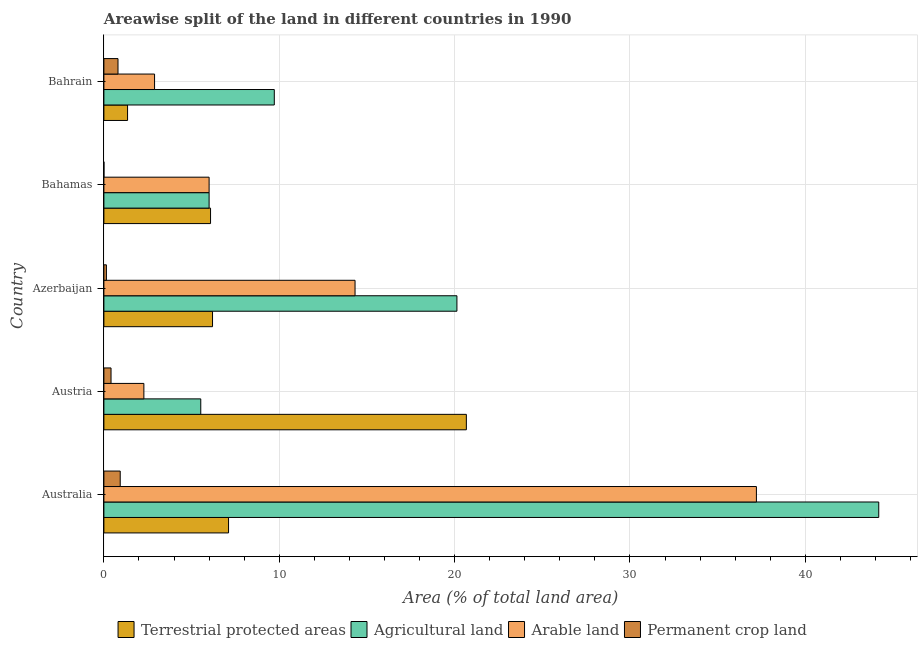How many different coloured bars are there?
Provide a short and direct response. 4. How many groups of bars are there?
Provide a succinct answer. 5. Are the number of bars on each tick of the Y-axis equal?
Your answer should be compact. Yes. How many bars are there on the 3rd tick from the top?
Offer a very short reply. 4. How many bars are there on the 4th tick from the bottom?
Make the answer very short. 4. What is the label of the 1st group of bars from the top?
Your answer should be compact. Bahrain. In how many cases, is the number of bars for a given country not equal to the number of legend labels?
Offer a very short reply. 0. What is the percentage of area under arable land in Bahrain?
Your answer should be compact. 2.89. Across all countries, what is the maximum percentage of area under permanent crop land?
Your answer should be compact. 0.93. Across all countries, what is the minimum percentage of area under permanent crop land?
Keep it short and to the point. 0. In which country was the percentage of area under arable land maximum?
Ensure brevity in your answer.  Australia. In which country was the percentage of area under arable land minimum?
Your answer should be compact. Austria. What is the total percentage of area under permanent crop land in the graph?
Offer a very short reply. 2.29. What is the difference between the percentage of area under agricultural land in Austria and that in Bahrain?
Your response must be concise. -4.19. What is the difference between the percentage of area under arable land in Australia and the percentage of land under terrestrial protection in Bahrain?
Offer a terse response. 35.86. What is the average percentage of land under terrestrial protection per country?
Offer a terse response. 8.28. What is the difference between the percentage of area under permanent crop land and percentage of land under terrestrial protection in Bahamas?
Your answer should be very brief. -6.08. What is the ratio of the percentage of area under permanent crop land in Austria to that in Azerbaijan?
Keep it short and to the point. 2.84. Is the percentage of area under permanent crop land in Austria less than that in Bahamas?
Your answer should be compact. No. What is the difference between the highest and the second highest percentage of area under arable land?
Provide a succinct answer. 22.89. What is the difference between the highest and the lowest percentage of land under terrestrial protection?
Offer a very short reply. 19.32. Is the sum of the percentage of area under arable land in Australia and Bahamas greater than the maximum percentage of area under agricultural land across all countries?
Make the answer very short. No. What does the 4th bar from the top in Austria represents?
Your answer should be compact. Terrestrial protected areas. What does the 4th bar from the bottom in Austria represents?
Ensure brevity in your answer.  Permanent crop land. Is it the case that in every country, the sum of the percentage of land under terrestrial protection and percentage of area under agricultural land is greater than the percentage of area under arable land?
Keep it short and to the point. Yes. How many bars are there?
Your answer should be compact. 20. Are all the bars in the graph horizontal?
Make the answer very short. Yes. What is the difference between two consecutive major ticks on the X-axis?
Give a very brief answer. 10. Are the values on the major ticks of X-axis written in scientific E-notation?
Make the answer very short. No. Does the graph contain any zero values?
Your answer should be compact. No. How are the legend labels stacked?
Provide a short and direct response. Horizontal. What is the title of the graph?
Make the answer very short. Areawise split of the land in different countries in 1990. What is the label or title of the X-axis?
Your answer should be very brief. Area (% of total land area). What is the label or title of the Y-axis?
Your answer should be very brief. Country. What is the Area (% of total land area) in Terrestrial protected areas in Australia?
Offer a very short reply. 7.11. What is the Area (% of total land area) of Agricultural land in Australia?
Offer a very short reply. 44.19. What is the Area (% of total land area) of Arable land in Australia?
Ensure brevity in your answer.  37.21. What is the Area (% of total land area) of Permanent crop land in Australia?
Keep it short and to the point. 0.93. What is the Area (% of total land area) in Terrestrial protected areas in Austria?
Your response must be concise. 20.67. What is the Area (% of total land area) in Agricultural land in Austria?
Offer a very short reply. 5.52. What is the Area (% of total land area) in Arable land in Austria?
Make the answer very short. 2.28. What is the Area (% of total land area) in Permanent crop land in Austria?
Your answer should be very brief. 0.41. What is the Area (% of total land area) of Terrestrial protected areas in Azerbaijan?
Keep it short and to the point. 6.2. What is the Area (% of total land area) of Agricultural land in Azerbaijan?
Offer a very short reply. 20.13. What is the Area (% of total land area) of Arable land in Azerbaijan?
Make the answer very short. 14.32. What is the Area (% of total land area) of Permanent crop land in Azerbaijan?
Make the answer very short. 0.14. What is the Area (% of total land area) of Terrestrial protected areas in Bahamas?
Your answer should be compact. 6.08. What is the Area (% of total land area) in Agricultural land in Bahamas?
Ensure brevity in your answer.  6. What is the Area (% of total land area) of Arable land in Bahamas?
Offer a very short reply. 6. What is the Area (% of total land area) in Permanent crop land in Bahamas?
Your response must be concise. 0. What is the Area (% of total land area) in Terrestrial protected areas in Bahrain?
Keep it short and to the point. 1.35. What is the Area (% of total land area) in Agricultural land in Bahrain?
Provide a short and direct response. 9.72. What is the Area (% of total land area) in Arable land in Bahrain?
Provide a succinct answer. 2.89. What is the Area (% of total land area) of Permanent crop land in Bahrain?
Ensure brevity in your answer.  0.8. Across all countries, what is the maximum Area (% of total land area) in Terrestrial protected areas?
Your response must be concise. 20.67. Across all countries, what is the maximum Area (% of total land area) of Agricultural land?
Your answer should be very brief. 44.19. Across all countries, what is the maximum Area (% of total land area) of Arable land?
Your response must be concise. 37.21. Across all countries, what is the maximum Area (% of total land area) of Permanent crop land?
Your answer should be very brief. 0.93. Across all countries, what is the minimum Area (% of total land area) in Terrestrial protected areas?
Provide a short and direct response. 1.35. Across all countries, what is the minimum Area (% of total land area) in Agricultural land?
Your response must be concise. 5.52. Across all countries, what is the minimum Area (% of total land area) of Arable land?
Provide a succinct answer. 2.28. Across all countries, what is the minimum Area (% of total land area) in Permanent crop land?
Your response must be concise. 0. What is the total Area (% of total land area) in Terrestrial protected areas in the graph?
Your answer should be compact. 41.4. What is the total Area (% of total land area) of Agricultural land in the graph?
Offer a very short reply. 85.56. What is the total Area (% of total land area) in Arable land in the graph?
Provide a short and direct response. 62.7. What is the total Area (% of total land area) in Permanent crop land in the graph?
Offer a very short reply. 2.29. What is the difference between the Area (% of total land area) in Terrestrial protected areas in Australia and that in Austria?
Make the answer very short. -13.56. What is the difference between the Area (% of total land area) of Agricultural land in Australia and that in Austria?
Provide a short and direct response. 38.66. What is the difference between the Area (% of total land area) of Arable land in Australia and that in Austria?
Offer a terse response. 34.93. What is the difference between the Area (% of total land area) of Permanent crop land in Australia and that in Austria?
Your answer should be very brief. 0.52. What is the difference between the Area (% of total land area) in Terrestrial protected areas in Australia and that in Azerbaijan?
Give a very brief answer. 0.91. What is the difference between the Area (% of total land area) in Agricultural land in Australia and that in Azerbaijan?
Offer a terse response. 24.05. What is the difference between the Area (% of total land area) of Arable land in Australia and that in Azerbaijan?
Your response must be concise. 22.89. What is the difference between the Area (% of total land area) in Permanent crop land in Australia and that in Azerbaijan?
Provide a succinct answer. 0.79. What is the difference between the Area (% of total land area) of Terrestrial protected areas in Australia and that in Bahamas?
Offer a very short reply. 1.03. What is the difference between the Area (% of total land area) in Agricultural land in Australia and that in Bahamas?
Ensure brevity in your answer.  38.19. What is the difference between the Area (% of total land area) in Arable land in Australia and that in Bahamas?
Your response must be concise. 31.21. What is the difference between the Area (% of total land area) of Permanent crop land in Australia and that in Bahamas?
Make the answer very short. 0.93. What is the difference between the Area (% of total land area) of Terrestrial protected areas in Australia and that in Bahrain?
Give a very brief answer. 5.76. What is the difference between the Area (% of total land area) of Agricultural land in Australia and that in Bahrain?
Your response must be concise. 34.47. What is the difference between the Area (% of total land area) in Arable land in Australia and that in Bahrain?
Keep it short and to the point. 34.32. What is the difference between the Area (% of total land area) in Permanent crop land in Australia and that in Bahrain?
Make the answer very short. 0.13. What is the difference between the Area (% of total land area) in Terrestrial protected areas in Austria and that in Azerbaijan?
Give a very brief answer. 14.47. What is the difference between the Area (% of total land area) in Agricultural land in Austria and that in Azerbaijan?
Your response must be concise. -14.61. What is the difference between the Area (% of total land area) in Arable land in Austria and that in Azerbaijan?
Offer a terse response. -12.04. What is the difference between the Area (% of total land area) in Permanent crop land in Austria and that in Azerbaijan?
Ensure brevity in your answer.  0.26. What is the difference between the Area (% of total land area) of Terrestrial protected areas in Austria and that in Bahamas?
Keep it short and to the point. 14.59. What is the difference between the Area (% of total land area) of Agricultural land in Austria and that in Bahamas?
Offer a terse response. -0.48. What is the difference between the Area (% of total land area) of Arable land in Austria and that in Bahamas?
Your answer should be compact. -3.72. What is the difference between the Area (% of total land area) in Permanent crop land in Austria and that in Bahamas?
Give a very brief answer. 0.4. What is the difference between the Area (% of total land area) of Terrestrial protected areas in Austria and that in Bahrain?
Offer a very short reply. 19.32. What is the difference between the Area (% of total land area) in Agricultural land in Austria and that in Bahrain?
Provide a short and direct response. -4.19. What is the difference between the Area (% of total land area) of Arable land in Austria and that in Bahrain?
Ensure brevity in your answer.  -0.61. What is the difference between the Area (% of total land area) in Permanent crop land in Austria and that in Bahrain?
Your answer should be compact. -0.4. What is the difference between the Area (% of total land area) in Terrestrial protected areas in Azerbaijan and that in Bahamas?
Your answer should be very brief. 0.11. What is the difference between the Area (% of total land area) in Agricultural land in Azerbaijan and that in Bahamas?
Ensure brevity in your answer.  14.13. What is the difference between the Area (% of total land area) of Arable land in Azerbaijan and that in Bahamas?
Give a very brief answer. 8.32. What is the difference between the Area (% of total land area) of Permanent crop land in Azerbaijan and that in Bahamas?
Offer a terse response. 0.14. What is the difference between the Area (% of total land area) in Terrestrial protected areas in Azerbaijan and that in Bahrain?
Ensure brevity in your answer.  4.85. What is the difference between the Area (% of total land area) of Agricultural land in Azerbaijan and that in Bahrain?
Offer a very short reply. 10.41. What is the difference between the Area (% of total land area) of Arable land in Azerbaijan and that in Bahrain?
Offer a terse response. 11.43. What is the difference between the Area (% of total land area) in Permanent crop land in Azerbaijan and that in Bahrain?
Your answer should be compact. -0.66. What is the difference between the Area (% of total land area) in Terrestrial protected areas in Bahamas and that in Bahrain?
Provide a succinct answer. 4.73. What is the difference between the Area (% of total land area) of Agricultural land in Bahamas and that in Bahrain?
Keep it short and to the point. -3.72. What is the difference between the Area (% of total land area) of Arable land in Bahamas and that in Bahrain?
Your answer should be very brief. 3.11. What is the difference between the Area (% of total land area) in Permanent crop land in Bahamas and that in Bahrain?
Give a very brief answer. -0.8. What is the difference between the Area (% of total land area) of Terrestrial protected areas in Australia and the Area (% of total land area) of Agricultural land in Austria?
Make the answer very short. 1.58. What is the difference between the Area (% of total land area) of Terrestrial protected areas in Australia and the Area (% of total land area) of Arable land in Austria?
Provide a succinct answer. 4.83. What is the difference between the Area (% of total land area) in Terrestrial protected areas in Australia and the Area (% of total land area) in Permanent crop land in Austria?
Your answer should be compact. 6.7. What is the difference between the Area (% of total land area) in Agricultural land in Australia and the Area (% of total land area) in Arable land in Austria?
Give a very brief answer. 41.91. What is the difference between the Area (% of total land area) of Agricultural land in Australia and the Area (% of total land area) of Permanent crop land in Austria?
Offer a very short reply. 43.78. What is the difference between the Area (% of total land area) in Arable land in Australia and the Area (% of total land area) in Permanent crop land in Austria?
Offer a very short reply. 36.8. What is the difference between the Area (% of total land area) in Terrestrial protected areas in Australia and the Area (% of total land area) in Agricultural land in Azerbaijan?
Provide a short and direct response. -13.02. What is the difference between the Area (% of total land area) in Terrestrial protected areas in Australia and the Area (% of total land area) in Arable land in Azerbaijan?
Your answer should be very brief. -7.21. What is the difference between the Area (% of total land area) in Terrestrial protected areas in Australia and the Area (% of total land area) in Permanent crop land in Azerbaijan?
Offer a very short reply. 6.97. What is the difference between the Area (% of total land area) in Agricultural land in Australia and the Area (% of total land area) in Arable land in Azerbaijan?
Provide a succinct answer. 29.86. What is the difference between the Area (% of total land area) of Agricultural land in Australia and the Area (% of total land area) of Permanent crop land in Azerbaijan?
Your response must be concise. 44.04. What is the difference between the Area (% of total land area) in Arable land in Australia and the Area (% of total land area) in Permanent crop land in Azerbaijan?
Your response must be concise. 37.07. What is the difference between the Area (% of total land area) in Terrestrial protected areas in Australia and the Area (% of total land area) in Agricultural land in Bahamas?
Ensure brevity in your answer.  1.11. What is the difference between the Area (% of total land area) in Terrestrial protected areas in Australia and the Area (% of total land area) in Arable land in Bahamas?
Your answer should be compact. 1.11. What is the difference between the Area (% of total land area) in Terrestrial protected areas in Australia and the Area (% of total land area) in Permanent crop land in Bahamas?
Your response must be concise. 7.11. What is the difference between the Area (% of total land area) of Agricultural land in Australia and the Area (% of total land area) of Arable land in Bahamas?
Make the answer very short. 38.19. What is the difference between the Area (% of total land area) of Agricultural land in Australia and the Area (% of total land area) of Permanent crop land in Bahamas?
Provide a short and direct response. 44.18. What is the difference between the Area (% of total land area) of Arable land in Australia and the Area (% of total land area) of Permanent crop land in Bahamas?
Ensure brevity in your answer.  37.21. What is the difference between the Area (% of total land area) of Terrestrial protected areas in Australia and the Area (% of total land area) of Agricultural land in Bahrain?
Give a very brief answer. -2.61. What is the difference between the Area (% of total land area) of Terrestrial protected areas in Australia and the Area (% of total land area) of Arable land in Bahrain?
Offer a terse response. 4.22. What is the difference between the Area (% of total land area) of Terrestrial protected areas in Australia and the Area (% of total land area) of Permanent crop land in Bahrain?
Your answer should be compact. 6.3. What is the difference between the Area (% of total land area) of Agricultural land in Australia and the Area (% of total land area) of Arable land in Bahrain?
Your answer should be compact. 41.3. What is the difference between the Area (% of total land area) of Agricultural land in Australia and the Area (% of total land area) of Permanent crop land in Bahrain?
Provide a succinct answer. 43.38. What is the difference between the Area (% of total land area) of Arable land in Australia and the Area (% of total land area) of Permanent crop land in Bahrain?
Make the answer very short. 36.4. What is the difference between the Area (% of total land area) of Terrestrial protected areas in Austria and the Area (% of total land area) of Agricultural land in Azerbaijan?
Give a very brief answer. 0.54. What is the difference between the Area (% of total land area) in Terrestrial protected areas in Austria and the Area (% of total land area) in Arable land in Azerbaijan?
Keep it short and to the point. 6.35. What is the difference between the Area (% of total land area) in Terrestrial protected areas in Austria and the Area (% of total land area) in Permanent crop land in Azerbaijan?
Keep it short and to the point. 20.53. What is the difference between the Area (% of total land area) of Agricultural land in Austria and the Area (% of total land area) of Arable land in Azerbaijan?
Your answer should be very brief. -8.8. What is the difference between the Area (% of total land area) in Agricultural land in Austria and the Area (% of total land area) in Permanent crop land in Azerbaijan?
Offer a terse response. 5.38. What is the difference between the Area (% of total land area) in Arable land in Austria and the Area (% of total land area) in Permanent crop land in Azerbaijan?
Provide a succinct answer. 2.14. What is the difference between the Area (% of total land area) in Terrestrial protected areas in Austria and the Area (% of total land area) in Agricultural land in Bahamas?
Make the answer very short. 14.67. What is the difference between the Area (% of total land area) in Terrestrial protected areas in Austria and the Area (% of total land area) in Arable land in Bahamas?
Your answer should be very brief. 14.67. What is the difference between the Area (% of total land area) of Terrestrial protected areas in Austria and the Area (% of total land area) of Permanent crop land in Bahamas?
Your answer should be very brief. 20.67. What is the difference between the Area (% of total land area) of Agricultural land in Austria and the Area (% of total land area) of Arable land in Bahamas?
Give a very brief answer. -0.48. What is the difference between the Area (% of total land area) of Agricultural land in Austria and the Area (% of total land area) of Permanent crop land in Bahamas?
Provide a succinct answer. 5.52. What is the difference between the Area (% of total land area) of Arable land in Austria and the Area (% of total land area) of Permanent crop land in Bahamas?
Provide a short and direct response. 2.28. What is the difference between the Area (% of total land area) in Terrestrial protected areas in Austria and the Area (% of total land area) in Agricultural land in Bahrain?
Your response must be concise. 10.95. What is the difference between the Area (% of total land area) in Terrestrial protected areas in Austria and the Area (% of total land area) in Arable land in Bahrain?
Your answer should be very brief. 17.78. What is the difference between the Area (% of total land area) in Terrestrial protected areas in Austria and the Area (% of total land area) in Permanent crop land in Bahrain?
Make the answer very short. 19.86. What is the difference between the Area (% of total land area) of Agricultural land in Austria and the Area (% of total land area) of Arable land in Bahrain?
Your answer should be very brief. 2.63. What is the difference between the Area (% of total land area) of Agricultural land in Austria and the Area (% of total land area) of Permanent crop land in Bahrain?
Offer a terse response. 4.72. What is the difference between the Area (% of total land area) of Arable land in Austria and the Area (% of total land area) of Permanent crop land in Bahrain?
Keep it short and to the point. 1.47. What is the difference between the Area (% of total land area) of Terrestrial protected areas in Azerbaijan and the Area (% of total land area) of Agricultural land in Bahamas?
Ensure brevity in your answer.  0.2. What is the difference between the Area (% of total land area) in Terrestrial protected areas in Azerbaijan and the Area (% of total land area) in Arable land in Bahamas?
Your answer should be compact. 0.2. What is the difference between the Area (% of total land area) of Terrestrial protected areas in Azerbaijan and the Area (% of total land area) of Permanent crop land in Bahamas?
Your response must be concise. 6.19. What is the difference between the Area (% of total land area) in Agricultural land in Azerbaijan and the Area (% of total land area) in Arable land in Bahamas?
Offer a terse response. 14.13. What is the difference between the Area (% of total land area) in Agricultural land in Azerbaijan and the Area (% of total land area) in Permanent crop land in Bahamas?
Your answer should be very brief. 20.13. What is the difference between the Area (% of total land area) in Arable land in Azerbaijan and the Area (% of total land area) in Permanent crop land in Bahamas?
Your answer should be very brief. 14.32. What is the difference between the Area (% of total land area) in Terrestrial protected areas in Azerbaijan and the Area (% of total land area) in Agricultural land in Bahrain?
Your answer should be very brief. -3.52. What is the difference between the Area (% of total land area) of Terrestrial protected areas in Azerbaijan and the Area (% of total land area) of Arable land in Bahrain?
Ensure brevity in your answer.  3.31. What is the difference between the Area (% of total land area) of Terrestrial protected areas in Azerbaijan and the Area (% of total land area) of Permanent crop land in Bahrain?
Your answer should be compact. 5.39. What is the difference between the Area (% of total land area) in Agricultural land in Azerbaijan and the Area (% of total land area) in Arable land in Bahrain?
Your response must be concise. 17.24. What is the difference between the Area (% of total land area) in Agricultural land in Azerbaijan and the Area (% of total land area) in Permanent crop land in Bahrain?
Make the answer very short. 19.33. What is the difference between the Area (% of total land area) of Arable land in Azerbaijan and the Area (% of total land area) of Permanent crop land in Bahrain?
Offer a terse response. 13.52. What is the difference between the Area (% of total land area) of Terrestrial protected areas in Bahamas and the Area (% of total land area) of Agricultural land in Bahrain?
Make the answer very short. -3.64. What is the difference between the Area (% of total land area) of Terrestrial protected areas in Bahamas and the Area (% of total land area) of Arable land in Bahrain?
Your answer should be very brief. 3.19. What is the difference between the Area (% of total land area) of Terrestrial protected areas in Bahamas and the Area (% of total land area) of Permanent crop land in Bahrain?
Make the answer very short. 5.28. What is the difference between the Area (% of total land area) of Agricultural land in Bahamas and the Area (% of total land area) of Arable land in Bahrain?
Ensure brevity in your answer.  3.11. What is the difference between the Area (% of total land area) of Agricultural land in Bahamas and the Area (% of total land area) of Permanent crop land in Bahrain?
Provide a short and direct response. 5.2. What is the difference between the Area (% of total land area) in Arable land in Bahamas and the Area (% of total land area) in Permanent crop land in Bahrain?
Offer a terse response. 5.2. What is the average Area (% of total land area) of Terrestrial protected areas per country?
Provide a short and direct response. 8.28. What is the average Area (% of total land area) of Agricultural land per country?
Provide a short and direct response. 17.11. What is the average Area (% of total land area) in Arable land per country?
Provide a succinct answer. 12.54. What is the average Area (% of total land area) in Permanent crop land per country?
Ensure brevity in your answer.  0.46. What is the difference between the Area (% of total land area) of Terrestrial protected areas and Area (% of total land area) of Agricultural land in Australia?
Make the answer very short. -37.08. What is the difference between the Area (% of total land area) of Terrestrial protected areas and Area (% of total land area) of Arable land in Australia?
Offer a very short reply. -30.1. What is the difference between the Area (% of total land area) in Terrestrial protected areas and Area (% of total land area) in Permanent crop land in Australia?
Provide a succinct answer. 6.18. What is the difference between the Area (% of total land area) in Agricultural land and Area (% of total land area) in Arable land in Australia?
Keep it short and to the point. 6.98. What is the difference between the Area (% of total land area) in Agricultural land and Area (% of total land area) in Permanent crop land in Australia?
Provide a succinct answer. 43.25. What is the difference between the Area (% of total land area) of Arable land and Area (% of total land area) of Permanent crop land in Australia?
Your response must be concise. 36.28. What is the difference between the Area (% of total land area) in Terrestrial protected areas and Area (% of total land area) in Agricultural land in Austria?
Offer a very short reply. 15.15. What is the difference between the Area (% of total land area) of Terrestrial protected areas and Area (% of total land area) of Arable land in Austria?
Your answer should be very brief. 18.39. What is the difference between the Area (% of total land area) of Terrestrial protected areas and Area (% of total land area) of Permanent crop land in Austria?
Ensure brevity in your answer.  20.26. What is the difference between the Area (% of total land area) of Agricultural land and Area (% of total land area) of Arable land in Austria?
Your answer should be very brief. 3.24. What is the difference between the Area (% of total land area) in Agricultural land and Area (% of total land area) in Permanent crop land in Austria?
Your response must be concise. 5.12. What is the difference between the Area (% of total land area) of Arable land and Area (% of total land area) of Permanent crop land in Austria?
Offer a very short reply. 1.87. What is the difference between the Area (% of total land area) in Terrestrial protected areas and Area (% of total land area) in Agricultural land in Azerbaijan?
Keep it short and to the point. -13.94. What is the difference between the Area (% of total land area) in Terrestrial protected areas and Area (% of total land area) in Arable land in Azerbaijan?
Offer a very short reply. -8.13. What is the difference between the Area (% of total land area) in Terrestrial protected areas and Area (% of total land area) in Permanent crop land in Azerbaijan?
Your answer should be very brief. 6.05. What is the difference between the Area (% of total land area) of Agricultural land and Area (% of total land area) of Arable land in Azerbaijan?
Give a very brief answer. 5.81. What is the difference between the Area (% of total land area) in Agricultural land and Area (% of total land area) in Permanent crop land in Azerbaijan?
Provide a short and direct response. 19.99. What is the difference between the Area (% of total land area) of Arable land and Area (% of total land area) of Permanent crop land in Azerbaijan?
Your answer should be compact. 14.18. What is the difference between the Area (% of total land area) in Terrestrial protected areas and Area (% of total land area) in Agricultural land in Bahamas?
Your response must be concise. 0.08. What is the difference between the Area (% of total land area) of Terrestrial protected areas and Area (% of total land area) of Arable land in Bahamas?
Keep it short and to the point. 0.08. What is the difference between the Area (% of total land area) of Terrestrial protected areas and Area (% of total land area) of Permanent crop land in Bahamas?
Provide a succinct answer. 6.08. What is the difference between the Area (% of total land area) of Agricultural land and Area (% of total land area) of Arable land in Bahamas?
Provide a short and direct response. 0. What is the difference between the Area (% of total land area) of Agricultural land and Area (% of total land area) of Permanent crop land in Bahamas?
Provide a short and direct response. 6. What is the difference between the Area (% of total land area) of Arable land and Area (% of total land area) of Permanent crop land in Bahamas?
Give a very brief answer. 6. What is the difference between the Area (% of total land area) in Terrestrial protected areas and Area (% of total land area) in Agricultural land in Bahrain?
Your response must be concise. -8.37. What is the difference between the Area (% of total land area) in Terrestrial protected areas and Area (% of total land area) in Arable land in Bahrain?
Your answer should be very brief. -1.54. What is the difference between the Area (% of total land area) of Terrestrial protected areas and Area (% of total land area) of Permanent crop land in Bahrain?
Ensure brevity in your answer.  0.55. What is the difference between the Area (% of total land area) of Agricultural land and Area (% of total land area) of Arable land in Bahrain?
Your response must be concise. 6.83. What is the difference between the Area (% of total land area) in Agricultural land and Area (% of total land area) in Permanent crop land in Bahrain?
Provide a short and direct response. 8.91. What is the difference between the Area (% of total land area) of Arable land and Area (% of total land area) of Permanent crop land in Bahrain?
Offer a very short reply. 2.08. What is the ratio of the Area (% of total land area) of Terrestrial protected areas in Australia to that in Austria?
Ensure brevity in your answer.  0.34. What is the ratio of the Area (% of total land area) in Agricultural land in Australia to that in Austria?
Your response must be concise. 8. What is the ratio of the Area (% of total land area) of Arable land in Australia to that in Austria?
Keep it short and to the point. 16.32. What is the ratio of the Area (% of total land area) in Permanent crop land in Australia to that in Austria?
Provide a succinct answer. 2.29. What is the ratio of the Area (% of total land area) in Terrestrial protected areas in Australia to that in Azerbaijan?
Your response must be concise. 1.15. What is the ratio of the Area (% of total land area) in Agricultural land in Australia to that in Azerbaijan?
Your answer should be very brief. 2.19. What is the ratio of the Area (% of total land area) in Arable land in Australia to that in Azerbaijan?
Provide a succinct answer. 2.6. What is the ratio of the Area (% of total land area) of Permanent crop land in Australia to that in Azerbaijan?
Your answer should be very brief. 6.51. What is the ratio of the Area (% of total land area) in Terrestrial protected areas in Australia to that in Bahamas?
Offer a terse response. 1.17. What is the ratio of the Area (% of total land area) in Agricultural land in Australia to that in Bahamas?
Provide a succinct answer. 7.36. What is the ratio of the Area (% of total land area) in Arable land in Australia to that in Bahamas?
Your answer should be compact. 6.2. What is the ratio of the Area (% of total land area) in Permanent crop land in Australia to that in Bahamas?
Your answer should be compact. 527.73. What is the ratio of the Area (% of total land area) of Terrestrial protected areas in Australia to that in Bahrain?
Your answer should be compact. 5.27. What is the ratio of the Area (% of total land area) of Agricultural land in Australia to that in Bahrain?
Make the answer very short. 4.55. What is the ratio of the Area (% of total land area) in Arable land in Australia to that in Bahrain?
Provide a succinct answer. 12.88. What is the ratio of the Area (% of total land area) in Permanent crop land in Australia to that in Bahrain?
Offer a very short reply. 1.16. What is the ratio of the Area (% of total land area) in Terrestrial protected areas in Austria to that in Azerbaijan?
Give a very brief answer. 3.34. What is the ratio of the Area (% of total land area) of Agricultural land in Austria to that in Azerbaijan?
Your response must be concise. 0.27. What is the ratio of the Area (% of total land area) of Arable land in Austria to that in Azerbaijan?
Your answer should be very brief. 0.16. What is the ratio of the Area (% of total land area) in Permanent crop land in Austria to that in Azerbaijan?
Make the answer very short. 2.84. What is the ratio of the Area (% of total land area) of Terrestrial protected areas in Austria to that in Bahamas?
Make the answer very short. 3.4. What is the ratio of the Area (% of total land area) in Agricultural land in Austria to that in Bahamas?
Ensure brevity in your answer.  0.92. What is the ratio of the Area (% of total land area) of Arable land in Austria to that in Bahamas?
Ensure brevity in your answer.  0.38. What is the ratio of the Area (% of total land area) of Permanent crop land in Austria to that in Bahamas?
Your answer should be compact. 230.46. What is the ratio of the Area (% of total land area) of Terrestrial protected areas in Austria to that in Bahrain?
Your response must be concise. 15.31. What is the ratio of the Area (% of total land area) in Agricultural land in Austria to that in Bahrain?
Your answer should be compact. 0.57. What is the ratio of the Area (% of total land area) in Arable land in Austria to that in Bahrain?
Your response must be concise. 0.79. What is the ratio of the Area (% of total land area) in Permanent crop land in Austria to that in Bahrain?
Keep it short and to the point. 0.51. What is the ratio of the Area (% of total land area) of Terrestrial protected areas in Azerbaijan to that in Bahamas?
Give a very brief answer. 1.02. What is the ratio of the Area (% of total land area) of Agricultural land in Azerbaijan to that in Bahamas?
Ensure brevity in your answer.  3.36. What is the ratio of the Area (% of total land area) of Arable land in Azerbaijan to that in Bahamas?
Your response must be concise. 2.39. What is the ratio of the Area (% of total land area) in Permanent crop land in Azerbaijan to that in Bahamas?
Provide a succinct answer. 81.09. What is the ratio of the Area (% of total land area) of Terrestrial protected areas in Azerbaijan to that in Bahrain?
Give a very brief answer. 4.59. What is the ratio of the Area (% of total land area) of Agricultural land in Azerbaijan to that in Bahrain?
Give a very brief answer. 2.07. What is the ratio of the Area (% of total land area) in Arable land in Azerbaijan to that in Bahrain?
Provide a short and direct response. 4.96. What is the ratio of the Area (% of total land area) in Permanent crop land in Azerbaijan to that in Bahrain?
Your answer should be very brief. 0.18. What is the ratio of the Area (% of total land area) of Terrestrial protected areas in Bahamas to that in Bahrain?
Provide a short and direct response. 4.5. What is the ratio of the Area (% of total land area) of Agricultural land in Bahamas to that in Bahrain?
Give a very brief answer. 0.62. What is the ratio of the Area (% of total land area) in Arable land in Bahamas to that in Bahrain?
Offer a terse response. 2.08. What is the ratio of the Area (% of total land area) of Permanent crop land in Bahamas to that in Bahrain?
Keep it short and to the point. 0. What is the difference between the highest and the second highest Area (% of total land area) in Terrestrial protected areas?
Make the answer very short. 13.56. What is the difference between the highest and the second highest Area (% of total land area) of Agricultural land?
Provide a short and direct response. 24.05. What is the difference between the highest and the second highest Area (% of total land area) of Arable land?
Give a very brief answer. 22.89. What is the difference between the highest and the second highest Area (% of total land area) in Permanent crop land?
Offer a very short reply. 0.13. What is the difference between the highest and the lowest Area (% of total land area) of Terrestrial protected areas?
Your answer should be very brief. 19.32. What is the difference between the highest and the lowest Area (% of total land area) in Agricultural land?
Your answer should be compact. 38.66. What is the difference between the highest and the lowest Area (% of total land area) of Arable land?
Ensure brevity in your answer.  34.93. What is the difference between the highest and the lowest Area (% of total land area) of Permanent crop land?
Ensure brevity in your answer.  0.93. 